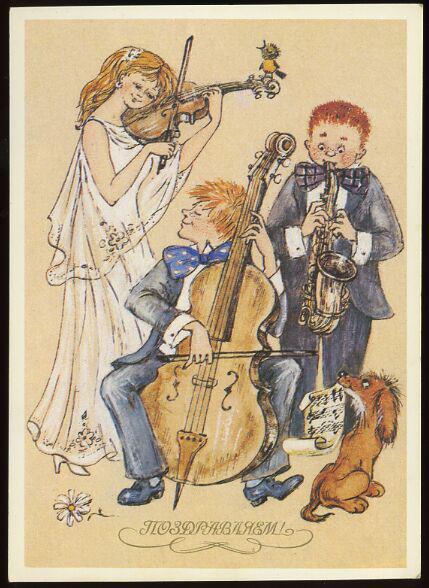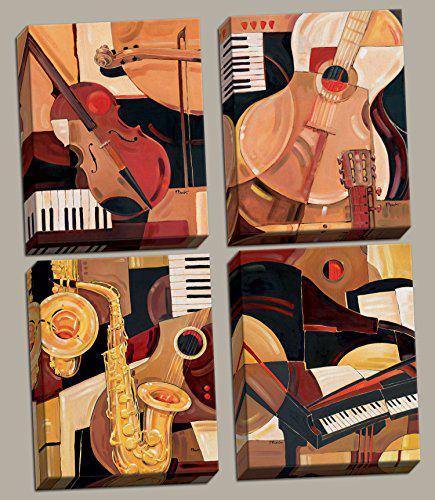The first image is the image on the left, the second image is the image on the right. Assess this claim about the two images: "One image shows four art renderings of musical instruments, including saxophone, violin and keyboard, and the other image depicts a person standing and playing a saxophone.". Correct or not? Answer yes or no. Yes. The first image is the image on the left, the second image is the image on the right. Given the left and right images, does the statement "One of the drawings depicts a dog." hold true? Answer yes or no. Yes. 